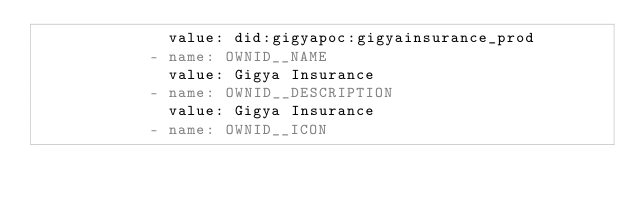Convert code to text. <code><loc_0><loc_0><loc_500><loc_500><_YAML_>              value: did:gigyapoc:gigyainsurance_prod
            - name: OWNID__NAME
              value: Gigya Insurance
            - name: OWNID__DESCRIPTION
              value: Gigya Insurance
            - name: OWNID__ICON</code> 